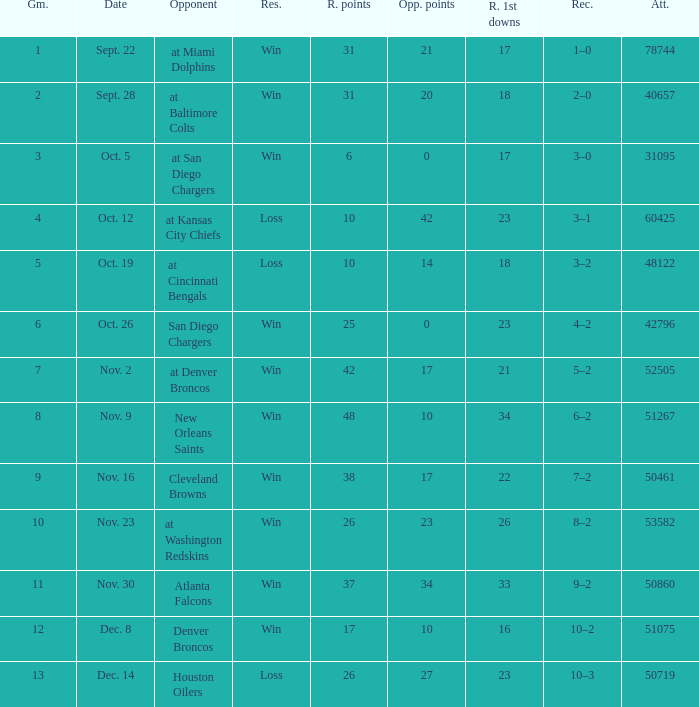How many different counts of the Raiders first downs are there for the game number 9? 1.0. 